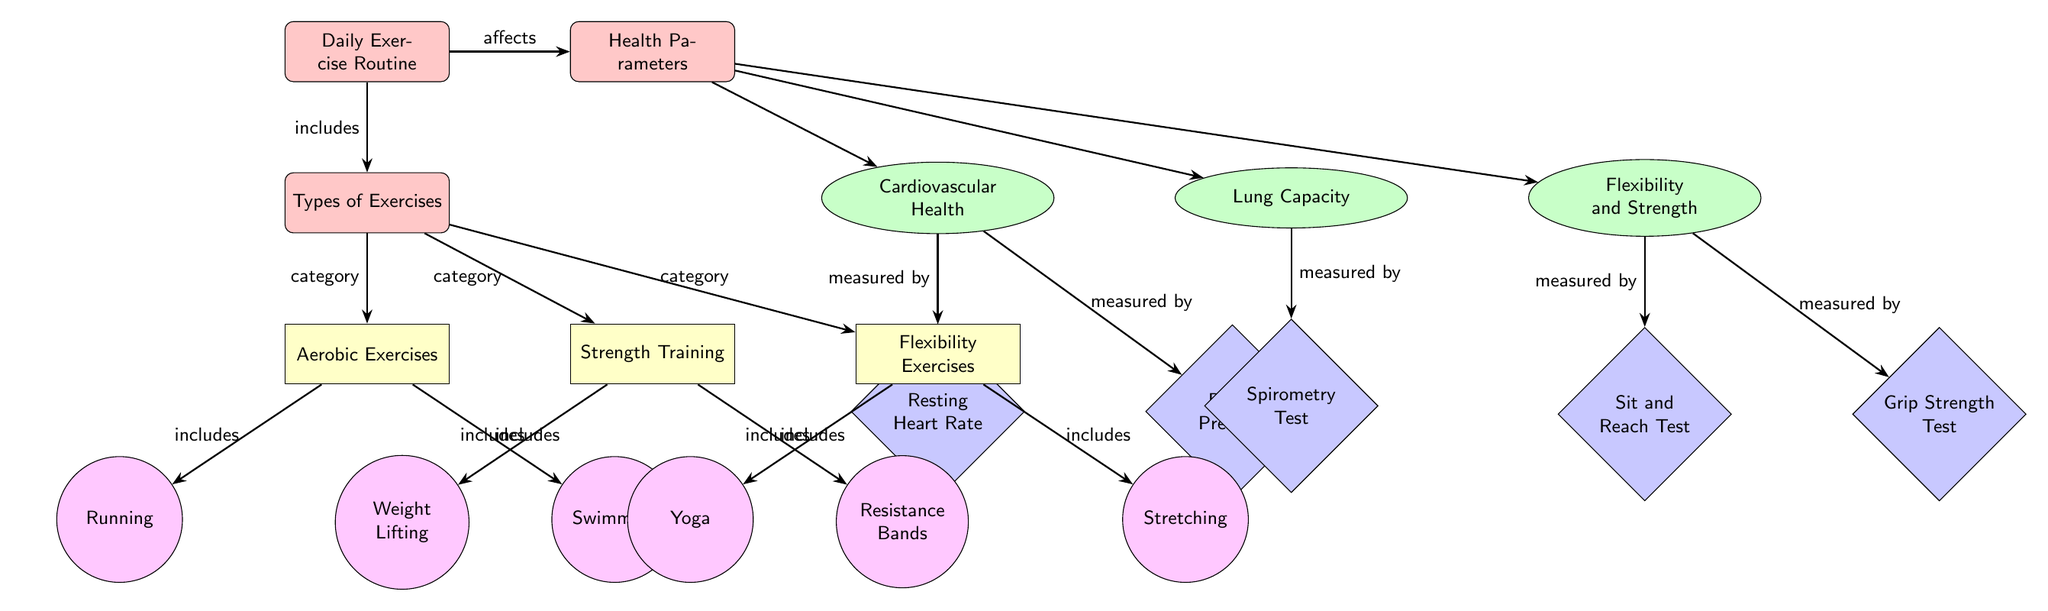What is the main category represented at the top of the diagram? The main category at the top of the diagram is labeled "Daily Exercise Routine," which represents the overall theme of the visual.
Answer: Daily Exercise Routine How many health parameters are illustrated in the diagram? The health parameters section indicates three distinct parameters: Cardiovascular Health, Lung Capacity, and Flexibility and Strength. Thus, there are three parameters.
Answer: 3 Which exercise type is directly associated with the activity "Swimming"? The activity "Swimming" is categorized under "Aerobic Exercises," which connects to the exercise type specified in the diagram.
Answer: Aerobic Exercises What metric measures Cardiovascular Health in the diagram? For Cardiovascular Health, there are two metrics listed: Resting Heart Rate and Blood Pressure. Both of these metrics help gauge this aspect of health.
Answer: Resting Heart Rate, Blood Pressure Which type of exercise includes "Yoga"? The exercise type that includes "Yoga" is labeled as "Flexibility Exercises," according to the connections shown in the diagram.
Answer: Flexibility Exercises What is the relationship between "Daily Exercise Routine" and "Health Parameters"? The diagram illustrates a direct relationship where "Daily Exercise Routine" affects "Health Parameters," indicating the impact of daily exercise on overall health.
Answer: affects Which metric is used to measure Lung Capacity? The metric used to measure Lung Capacity in the diagram is specified as "Spirometry Test," which connects directly to that health parameter.
Answer: Spirometry Test How many different activities are listed under "Strength Training"? Under the "Strength Training" category, there are two specific activities mentioned: Weight Lifting and Resistance Bands. Thus, there are two activities in this category.
Answer: 2 What does the arrow from "strength" to "weightLifting" indicate? The arrow connecting "strength" to "weightLifting" indicates that Weight Lifting is included within the Strength Training category, demonstrating a specific type of strength training exercise.
Answer: includes What type of exercise affects resting heart rate? Aerobic exercises, specifically through activities like running and swimming, affect the resting heart rate, which is a metric under Cardiovascular Health.
Answer: Aerobic Exercises 